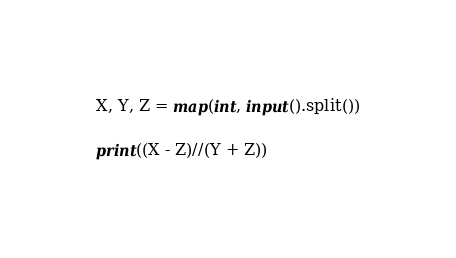Convert code to text. <code><loc_0><loc_0><loc_500><loc_500><_Python_>X, Y, Z = map(int, input().split())

print((X - Z)//(Y + Z))</code> 